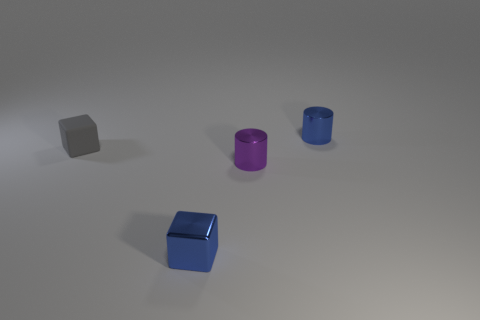Add 4 gray rubber blocks. How many objects exist? 8 Subtract all blue cubes. How many cubes are left? 1 Subtract 1 blocks. How many blocks are left? 1 Add 4 big blue rubber spheres. How many big blue rubber spheres exist? 4 Subtract 1 purple cylinders. How many objects are left? 3 Subtract all green cylinders. Subtract all red spheres. How many cylinders are left? 2 Subtract all yellow balls. How many blue cylinders are left? 1 Subtract all small green rubber cylinders. Subtract all blue objects. How many objects are left? 2 Add 4 matte blocks. How many matte blocks are left? 5 